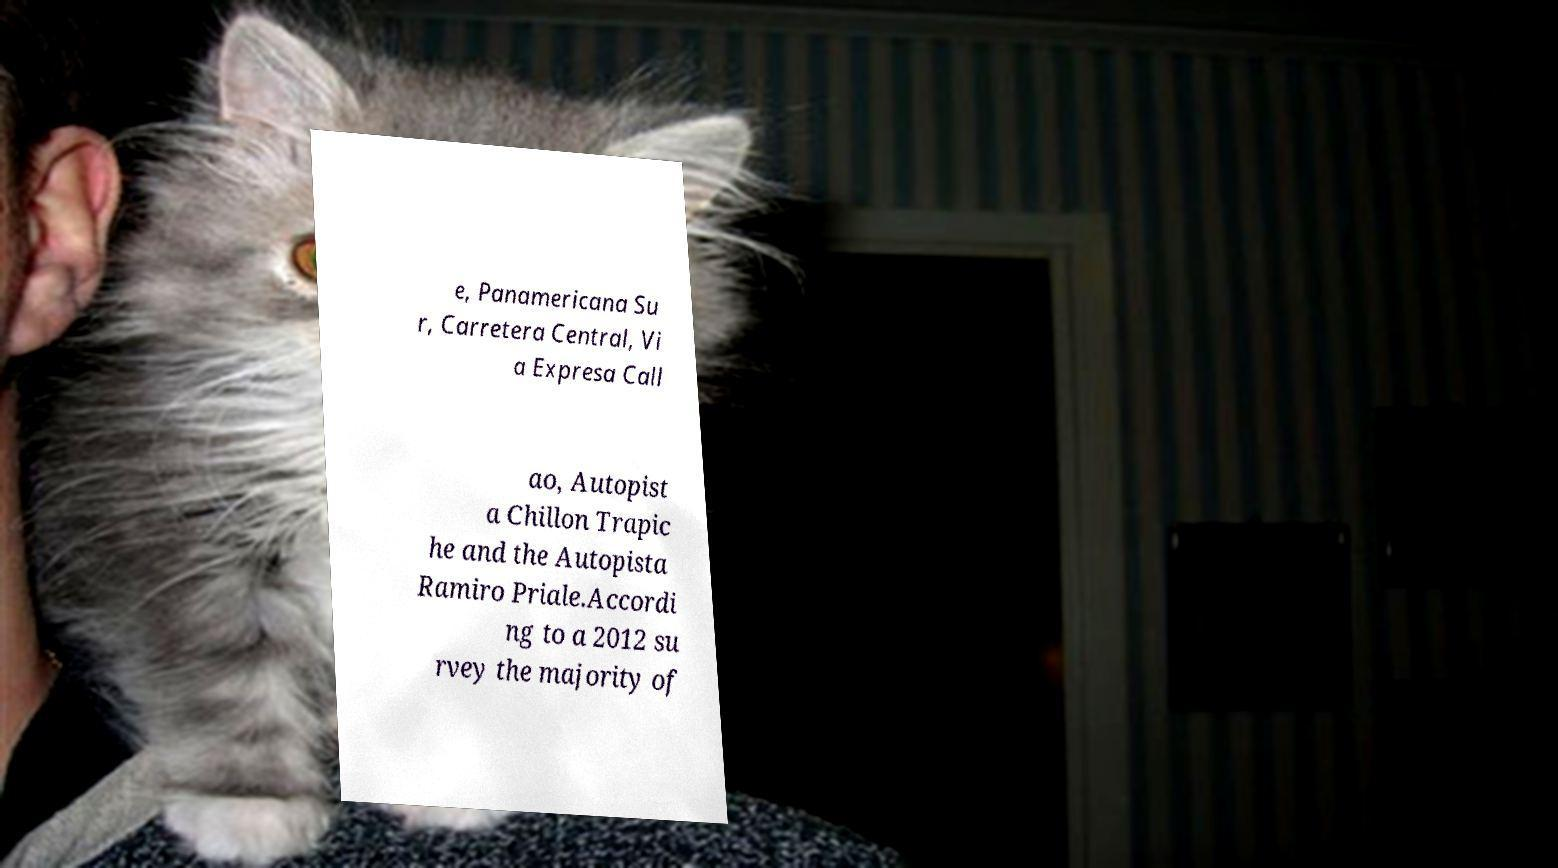I need the written content from this picture converted into text. Can you do that? e, Panamericana Su r, Carretera Central, Vi a Expresa Call ao, Autopist a Chillon Trapic he and the Autopista Ramiro Priale.Accordi ng to a 2012 su rvey the majority of 